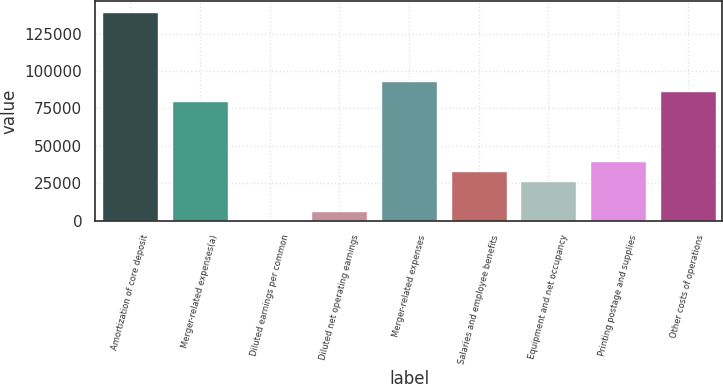<chart> <loc_0><loc_0><loc_500><loc_500><bar_chart><fcel>Amortization of core deposit<fcel>Merger-related expenses(a)<fcel>Diluted earnings per common<fcel>Diluted net operating earnings<fcel>Merger-related expenses<fcel>Salaries and employee benefits<fcel>Equipment and net occupancy<fcel>Printing postage and supplies<fcel>Other costs of operations<nl><fcel>139614<fcel>79782<fcel>5.95<fcel>6653.96<fcel>93078<fcel>33246<fcel>26598<fcel>39894<fcel>86430<nl></chart> 